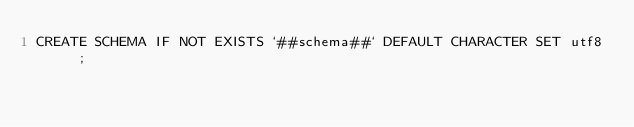<code> <loc_0><loc_0><loc_500><loc_500><_SQL_>CREATE SCHEMA IF NOT EXISTS `##schema##` DEFAULT CHARACTER SET utf8 ;
</code> 